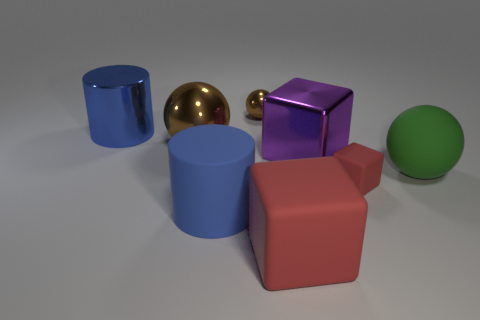There is a small object that is right of the small brown thing; what material is it?
Offer a very short reply. Rubber. What size is the other cube that is the same color as the small cube?
Provide a succinct answer. Large. Are there any rubber things that have the same size as the green sphere?
Your answer should be very brief. Yes. There is a big purple thing; is it the same shape as the rubber object on the left side of the small brown shiny ball?
Provide a short and direct response. No. Does the blue object behind the large rubber ball have the same size as the cube that is to the right of the big metal cube?
Give a very brief answer. No. What number of other things are there of the same shape as the big blue rubber thing?
Provide a short and direct response. 1. What material is the big thing that is in front of the large blue matte cylinder in front of the small brown sphere made of?
Offer a terse response. Rubber. What number of metallic objects are either big red objects or large cylinders?
Keep it short and to the point. 1. Are there any other things that have the same material as the green ball?
Provide a short and direct response. Yes. Are there any large green objects that are left of the large blue cylinder that is right of the blue metal cylinder?
Your response must be concise. No. 